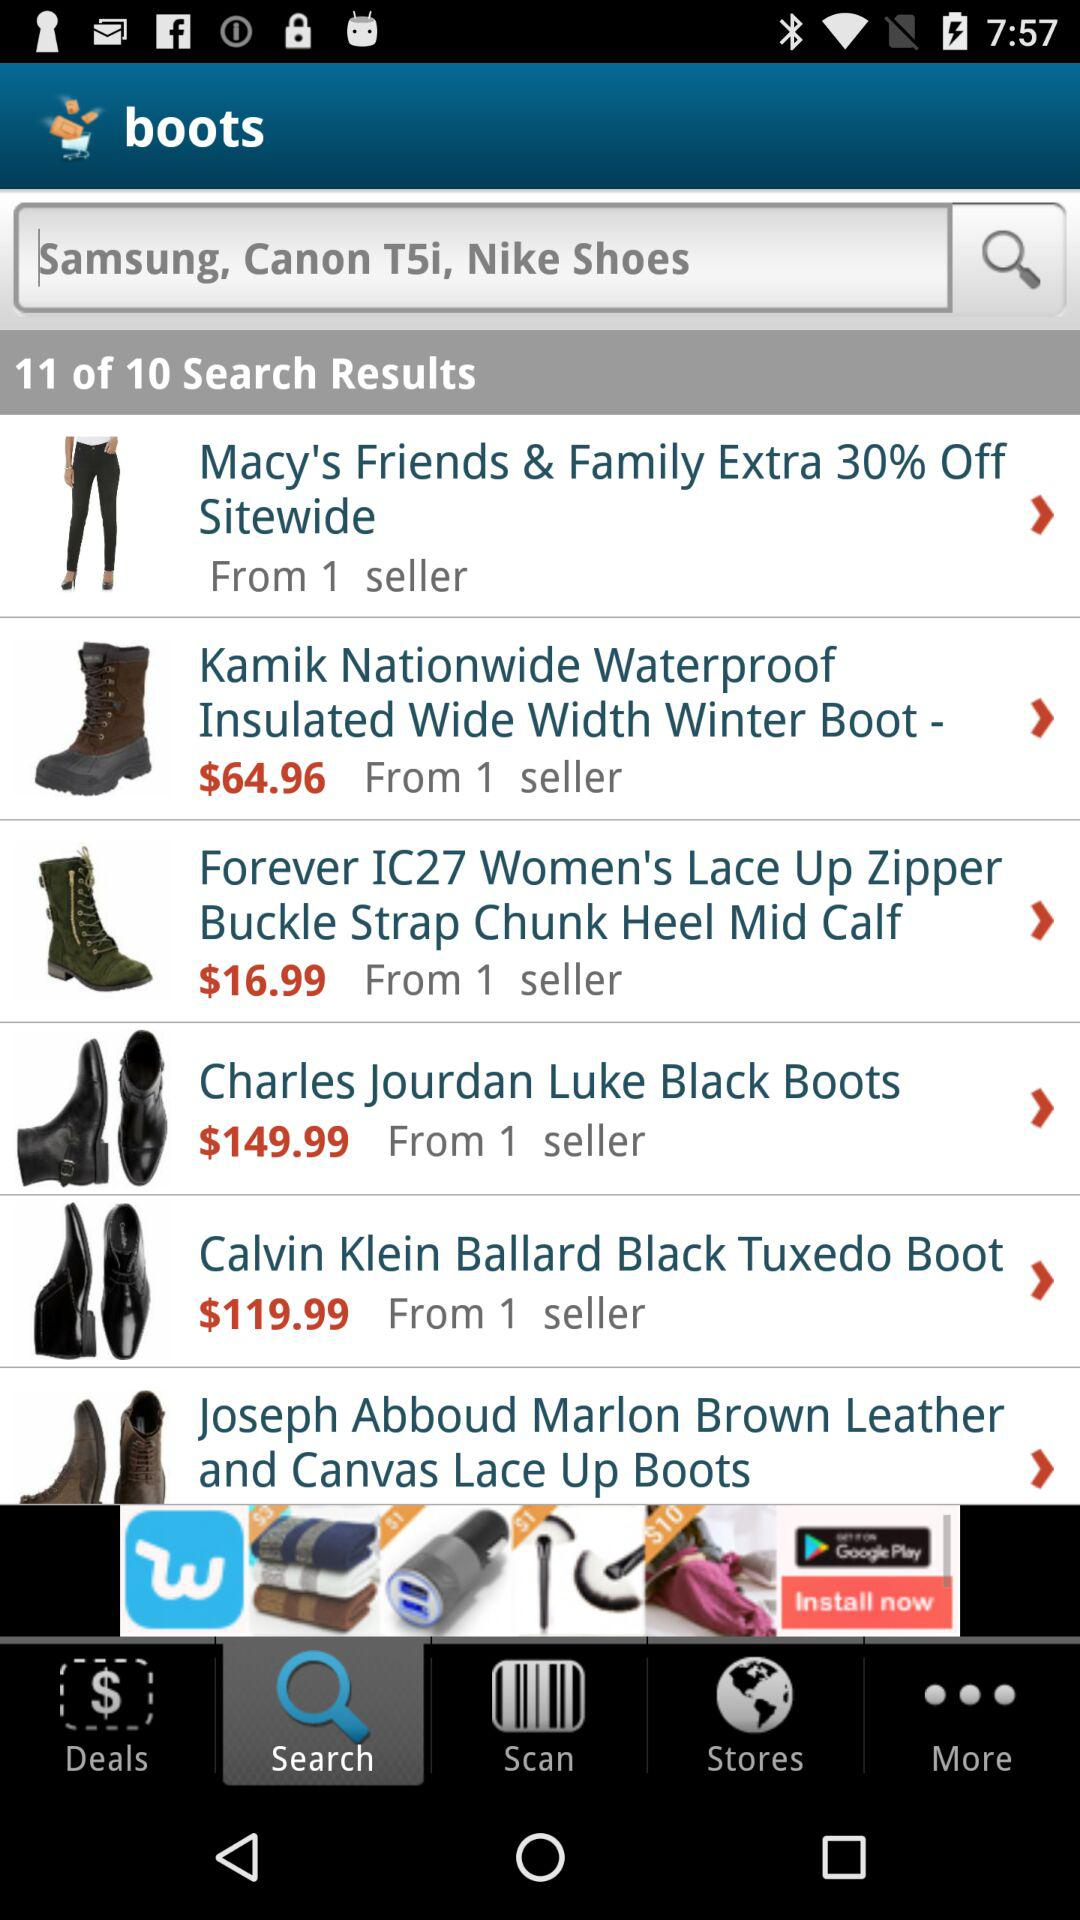How many search results are there? There are 11 search results. 